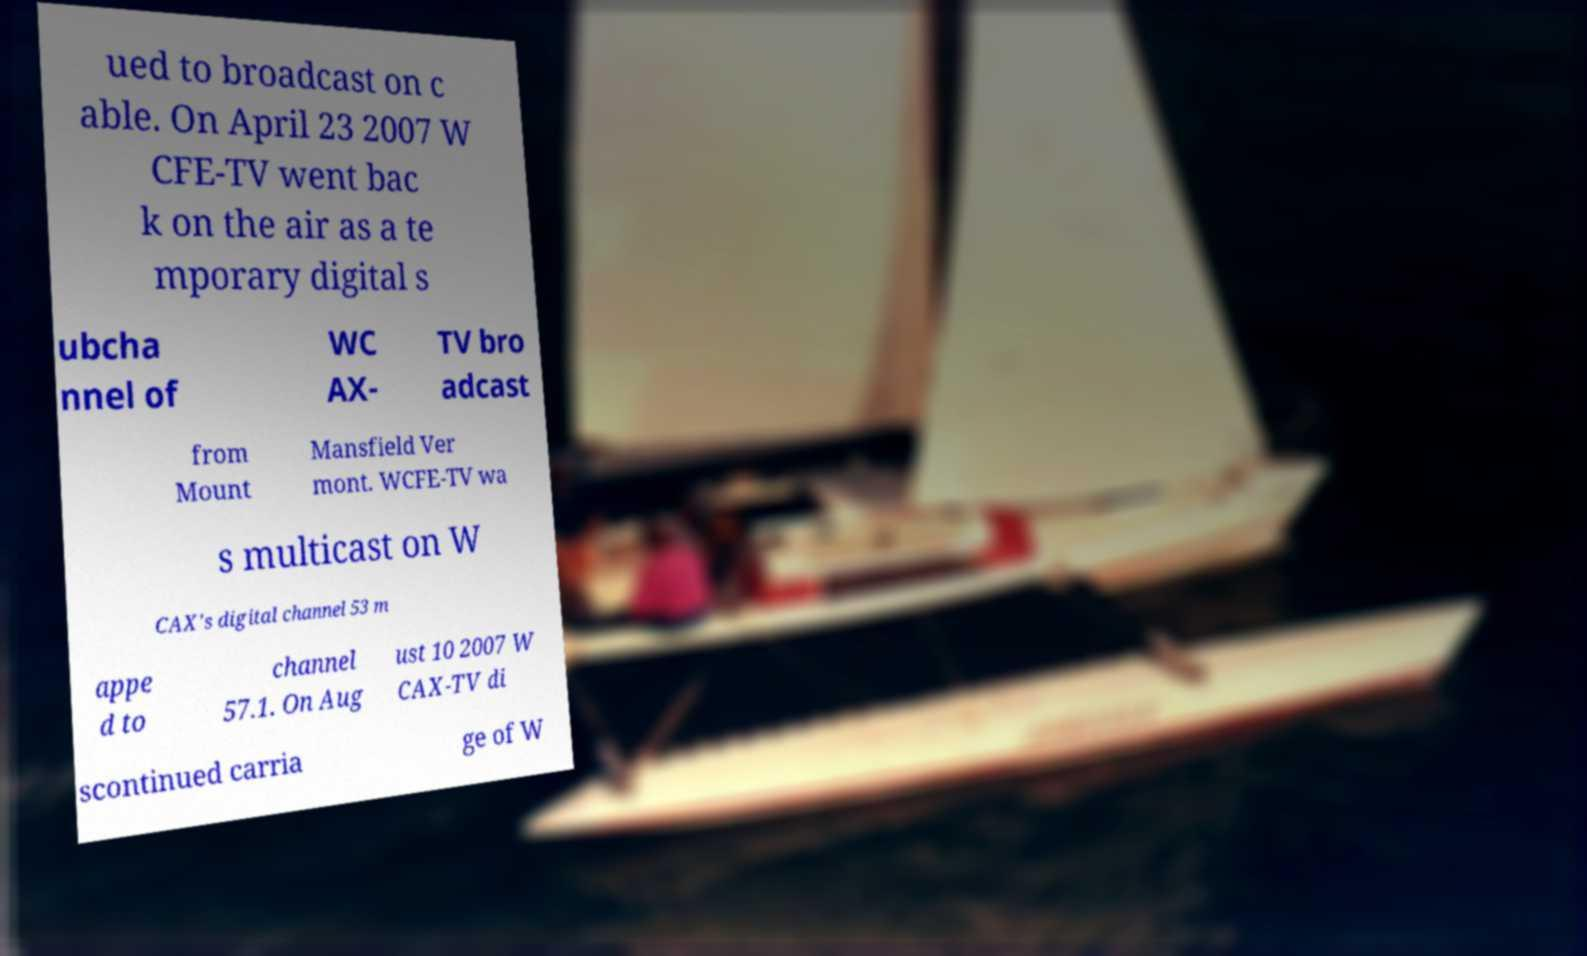Please identify and transcribe the text found in this image. ued to broadcast on c able. On April 23 2007 W CFE-TV went bac k on the air as a te mporary digital s ubcha nnel of WC AX- TV bro adcast from Mount Mansfield Ver mont. WCFE-TV wa s multicast on W CAX's digital channel 53 m appe d to channel 57.1. On Aug ust 10 2007 W CAX-TV di scontinued carria ge of W 